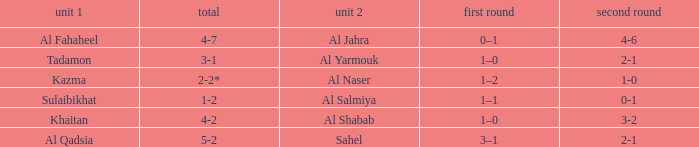What is the 1st leg of the match with a 2nd leg of 3-2? 1–0. 